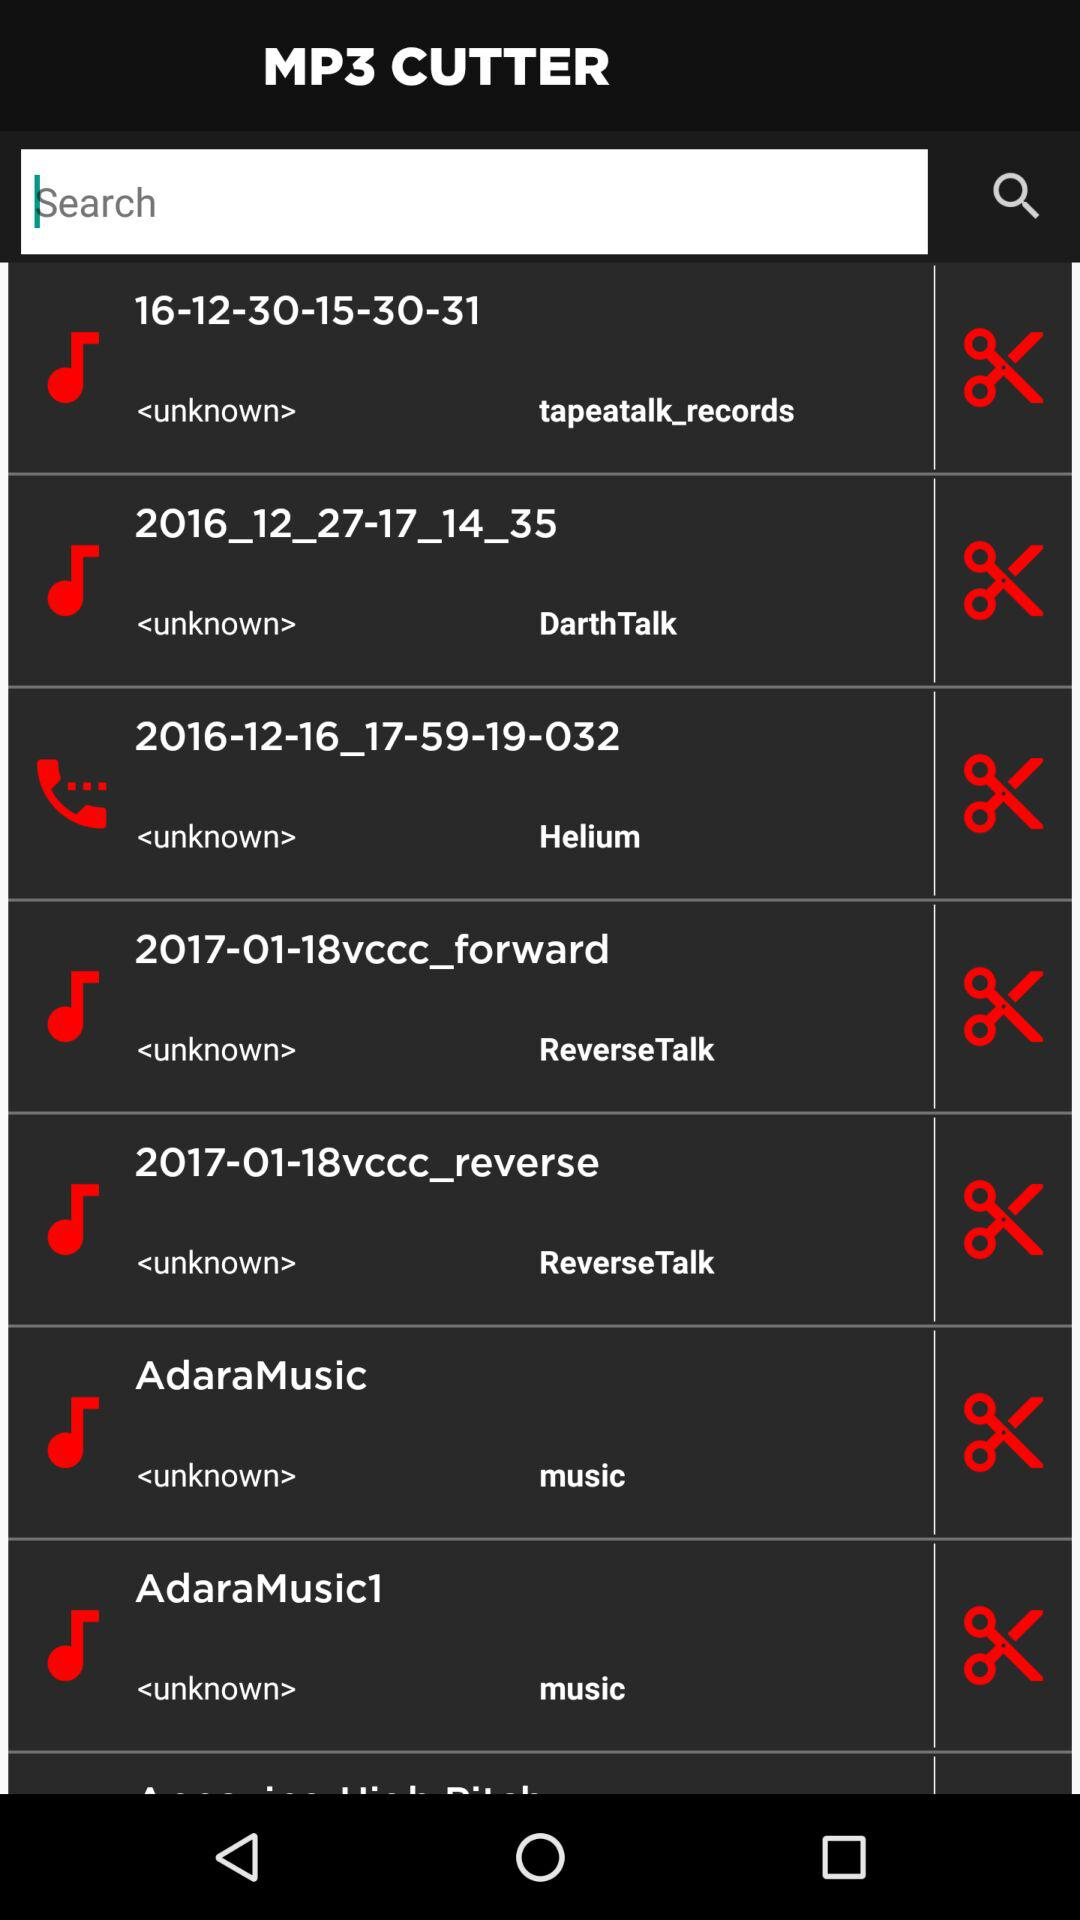What is the date of the dearth talk?
When the provided information is insufficient, respond with <no answer>. <no answer> 